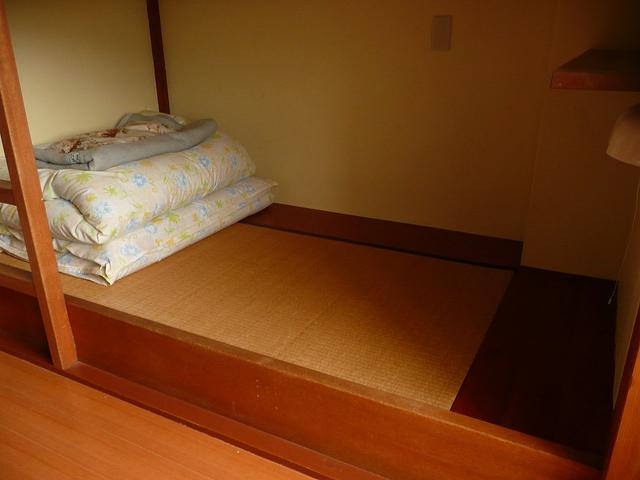Is this a bed?
Give a very brief answer. Yes. What color are the flowers on the folded up material?
Keep it brief. Blue. Is there a ladder?
Quick response, please. Yes. 